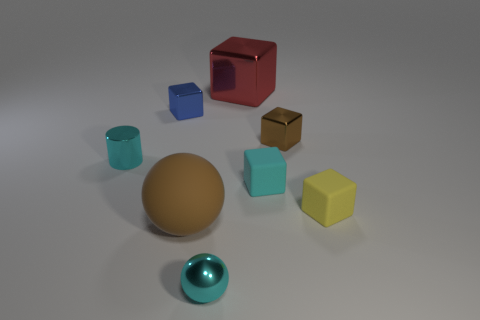Subtract all brown cubes. How many cubes are left? 4 Subtract all tiny cyan matte cubes. How many cubes are left? 4 Subtract all purple cubes. Subtract all green balls. How many cubes are left? 5 Add 1 tiny brown shiny things. How many objects exist? 9 Subtract all cubes. How many objects are left? 3 Add 5 large yellow rubber blocks. How many large yellow rubber blocks exist? 5 Subtract 0 blue cylinders. How many objects are left? 8 Subtract all cyan metal cylinders. Subtract all blue cubes. How many objects are left? 6 Add 8 large objects. How many large objects are left? 10 